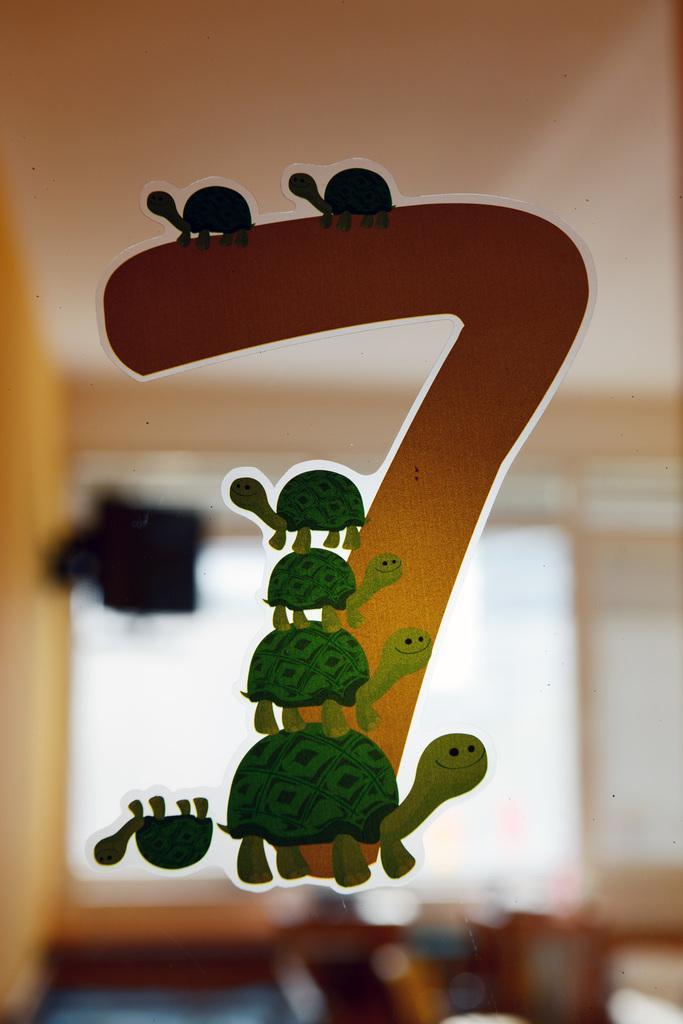Could you give a brief overview of what you see in this image? In this image we can see a seven number sticker on which group of turtles are designed. 